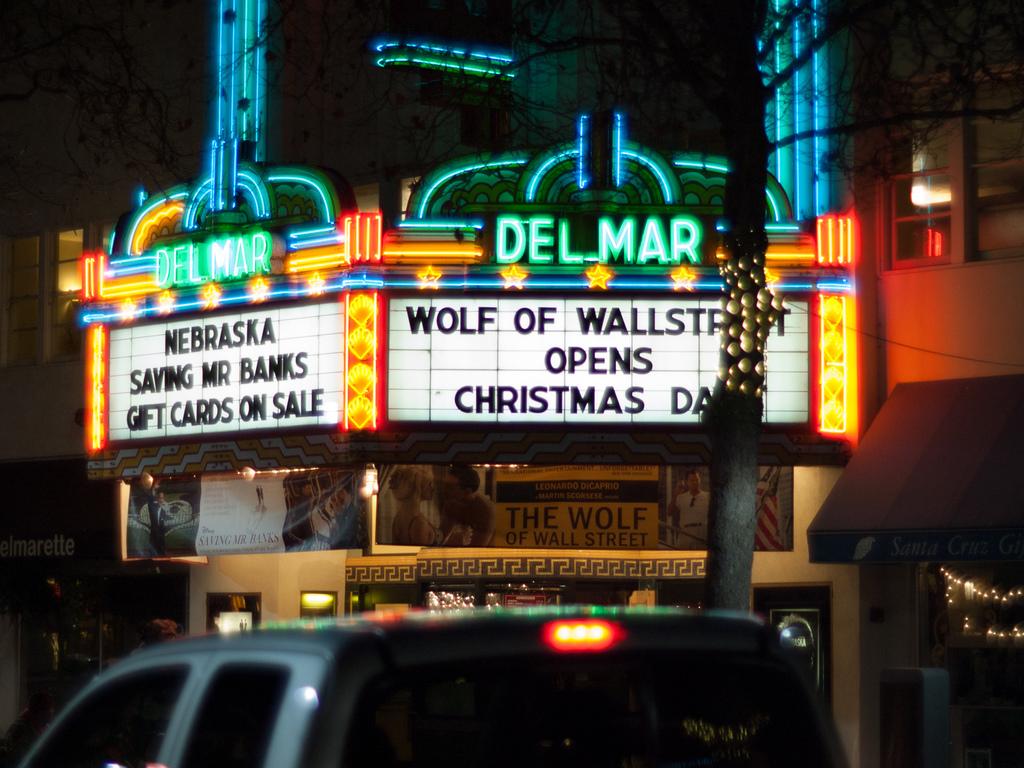What movie opens on christmas day?
Provide a succinct answer. Wolf of wallstreet. What theater is this?
Give a very brief answer. Delmar. 